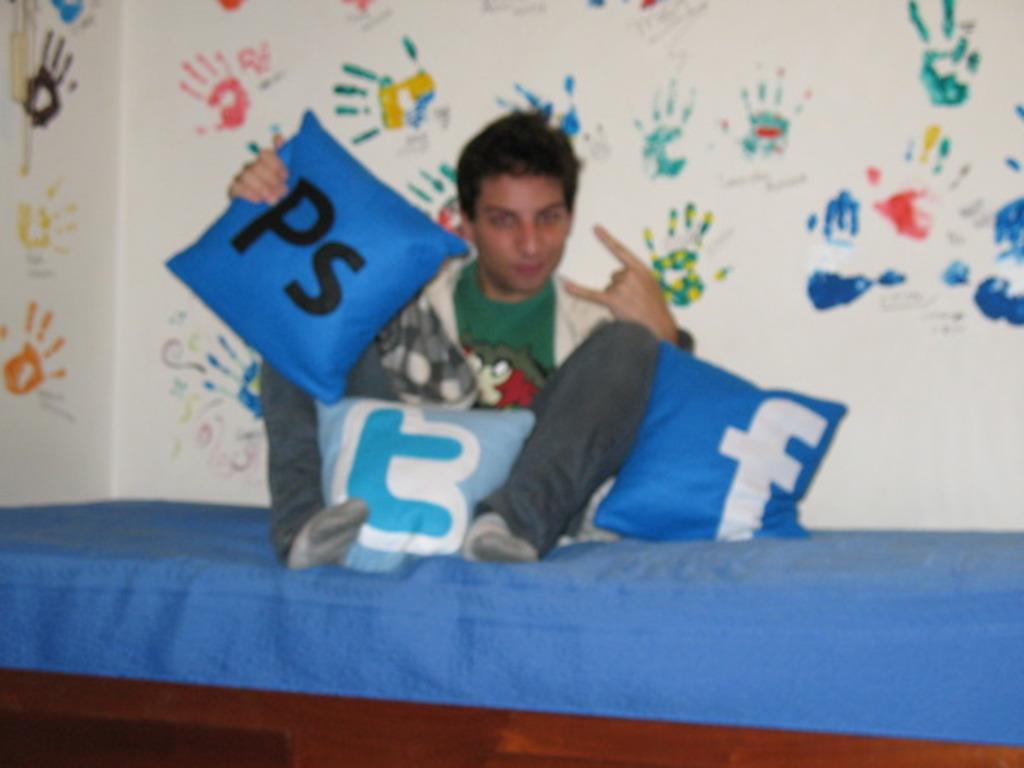Describe this image in one or two sentences. Here I can see a man sitting on a bed. Along with the man there are few pillows. At the back of this man there is a wall on which I can see few handprints. 